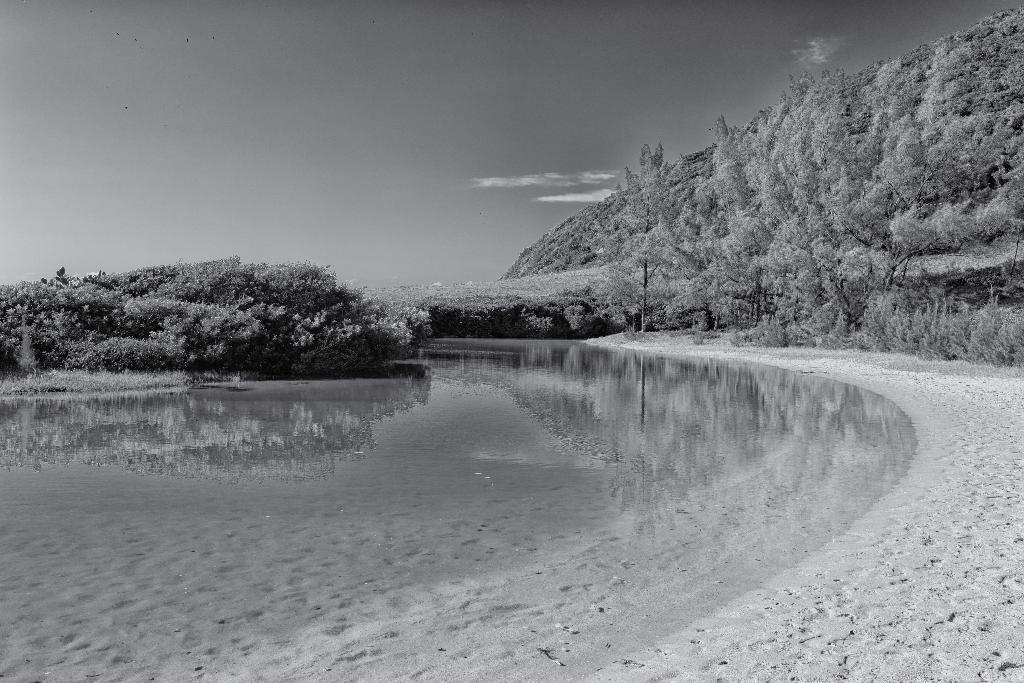What is the main subject in the center of the image? There is water in the center of the image. What can be seen in the background of the image? There are trees and the sky visible in the background of the image. What type of natural environment is on the right side of the image? There is a seashore on the right side of the image. What type of whip can be seen being used on the seashore in the image? There is no whip present in the image, and therefore no such activity can be observed. 